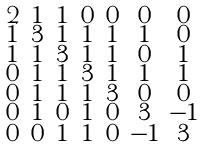Convert formula to latex. <formula><loc_0><loc_0><loc_500><loc_500>\begin{smallmatrix} 2 & 1 & 1 & 0 & 0 & 0 & 0 \\ 1 & 3 & 1 & 1 & 1 & 1 & 0 \\ 1 & 1 & 3 & 1 & 1 & 0 & 1 \\ 0 & 1 & 1 & 3 & 1 & 1 & 1 \\ 0 & 1 & 1 & 1 & 3 & 0 & 0 \\ 0 & 1 & 0 & 1 & 0 & 3 & - 1 \\ 0 & 0 & 1 & 1 & 0 & - 1 & 3 \end{smallmatrix}</formula> 